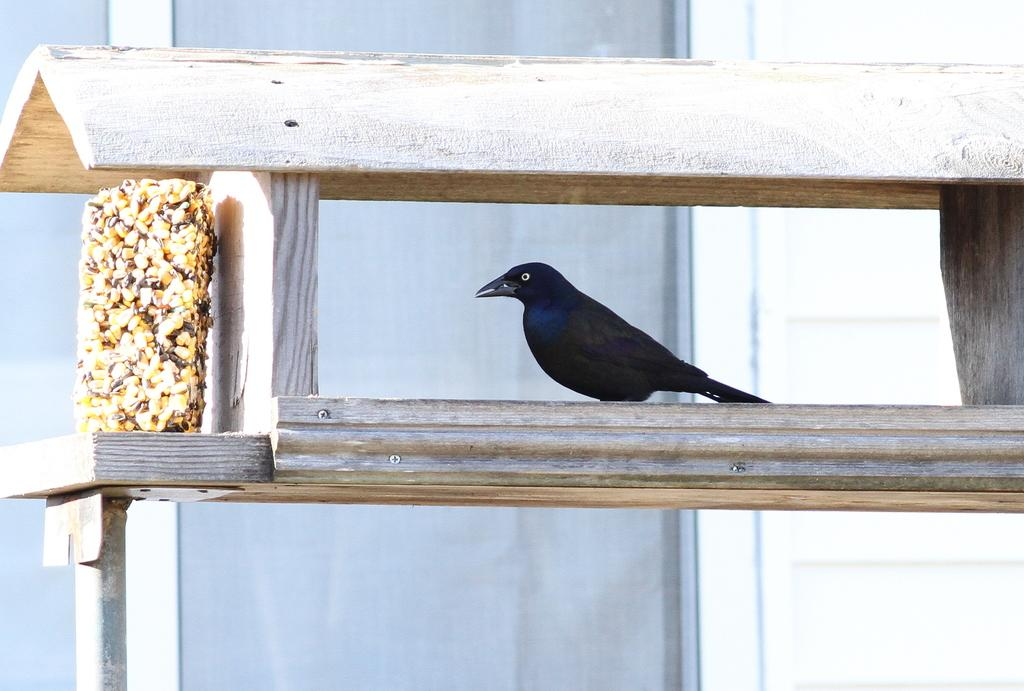What type of bird is in the image? There is a crow in the image. Where is the crow located? The crow is inside a wooden structure. Can you describe the position of the wooden structure in the image? The wooden structure is in the foreground area of the image. What can be seen in the background of the image? There is a window visible in the background of the image. What type of wine is the crow drinking in the image? There is no wine present in the image, and the crow is not shown drinking anything. 